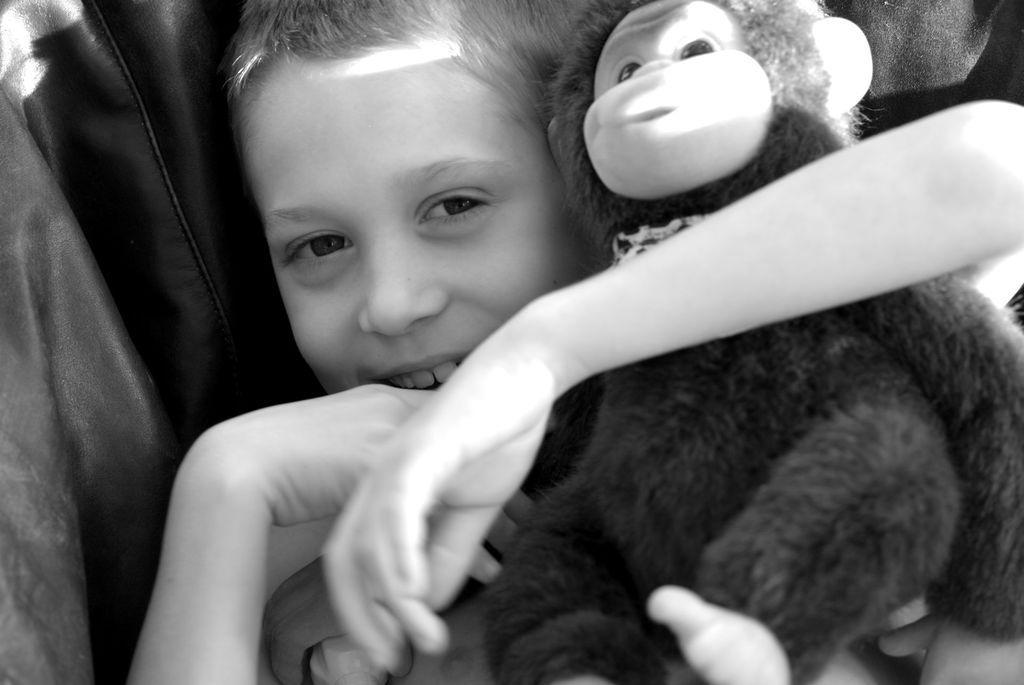Describe this image in one or two sentences. A boy is holding monkey toy in his arms. 